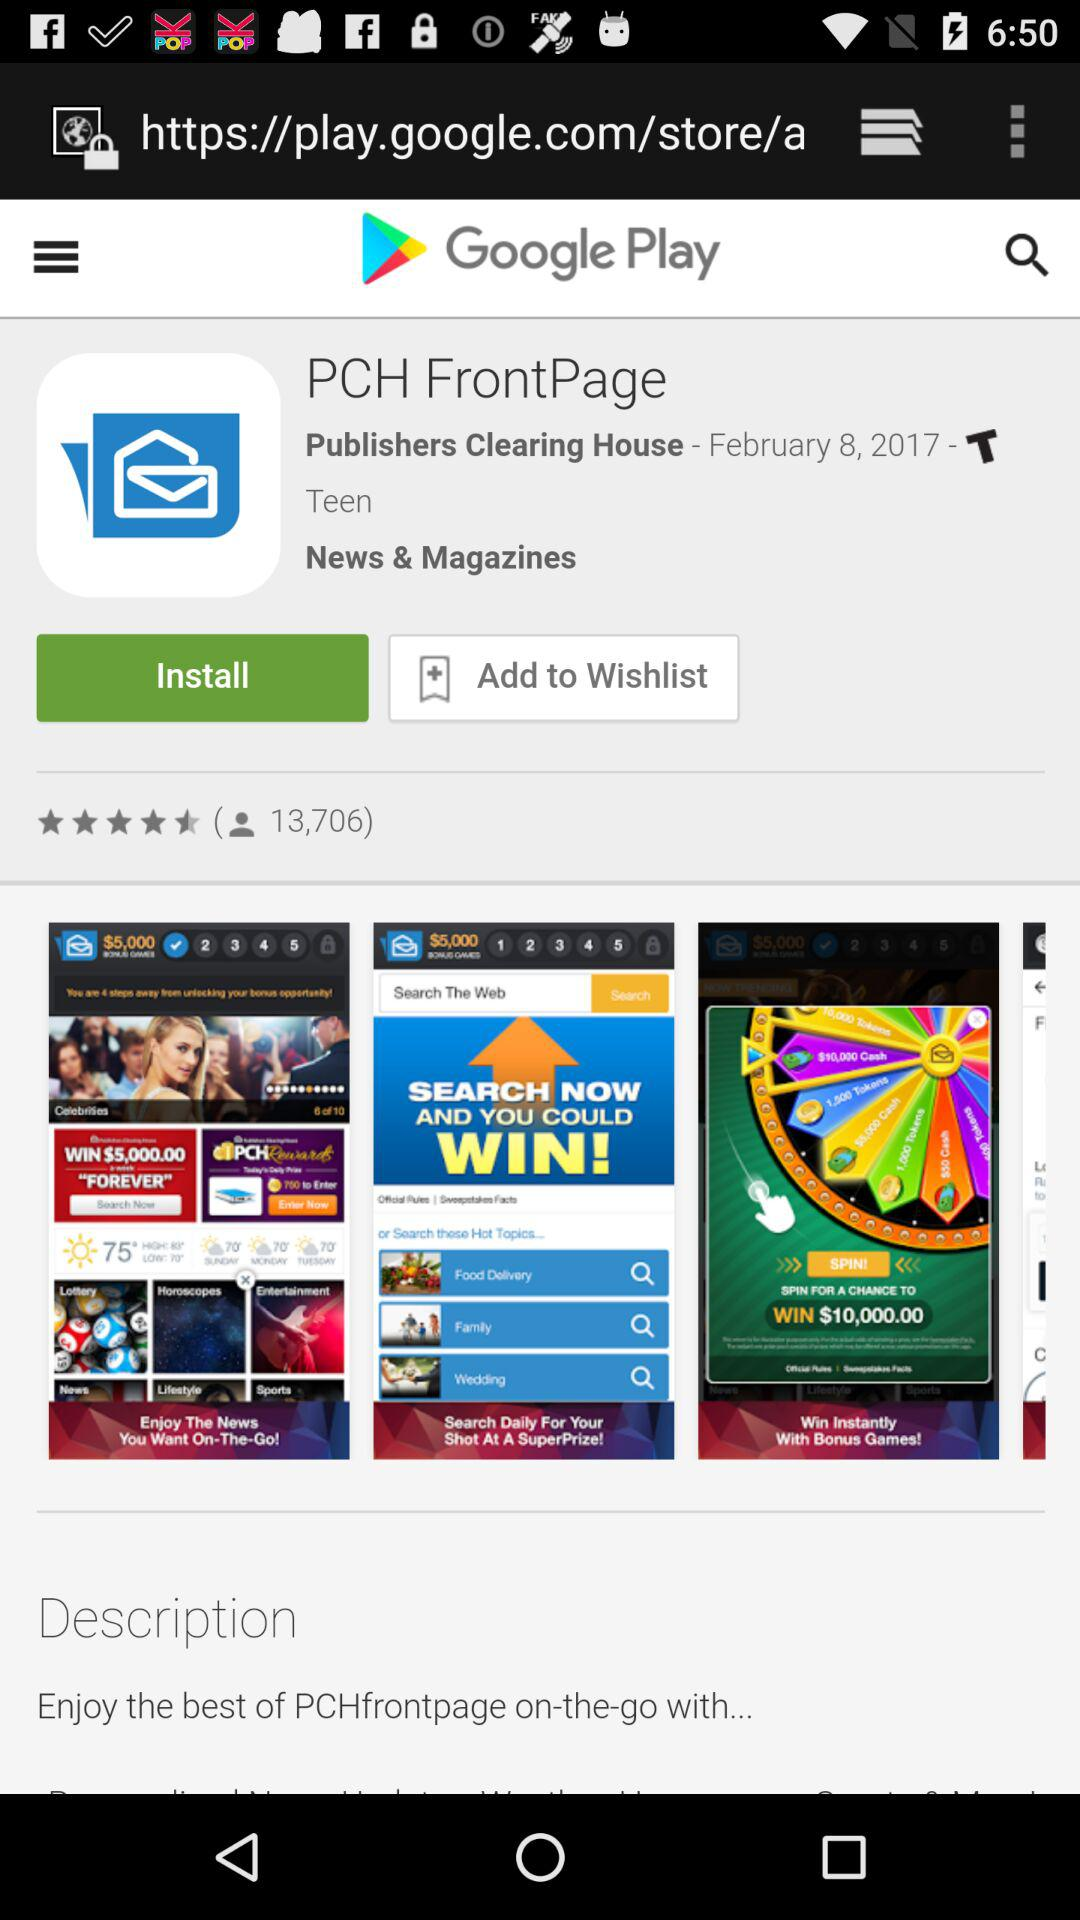What is the name of the application? The names of the applications are "Google Play" and "PCH FrontPage". 